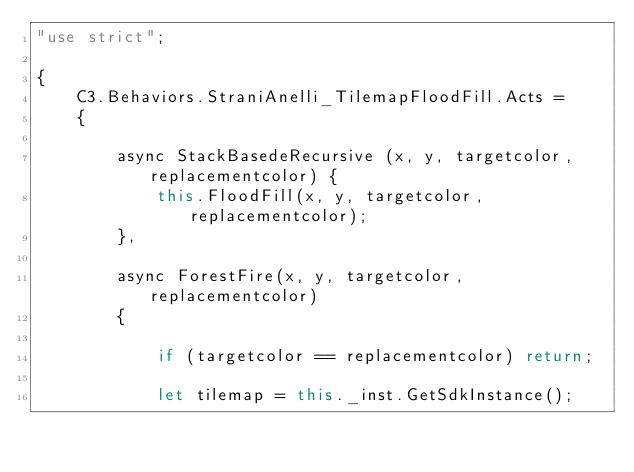Convert code to text. <code><loc_0><loc_0><loc_500><loc_500><_JavaScript_>"use strict";

{
	C3.Behaviors.StraniAnelli_TilemapFloodFill.Acts =
	{

		async StackBasedeRecursive (x, y, targetcolor, replacementcolor) {
			this.FloodFill(x, y, targetcolor, replacementcolor);
		},

		async ForestFire(x, y, targetcolor, replacementcolor)
		{

			if (targetcolor == replacementcolor) return;

			let tilemap = this._inst.GetSdkInstance();</code> 